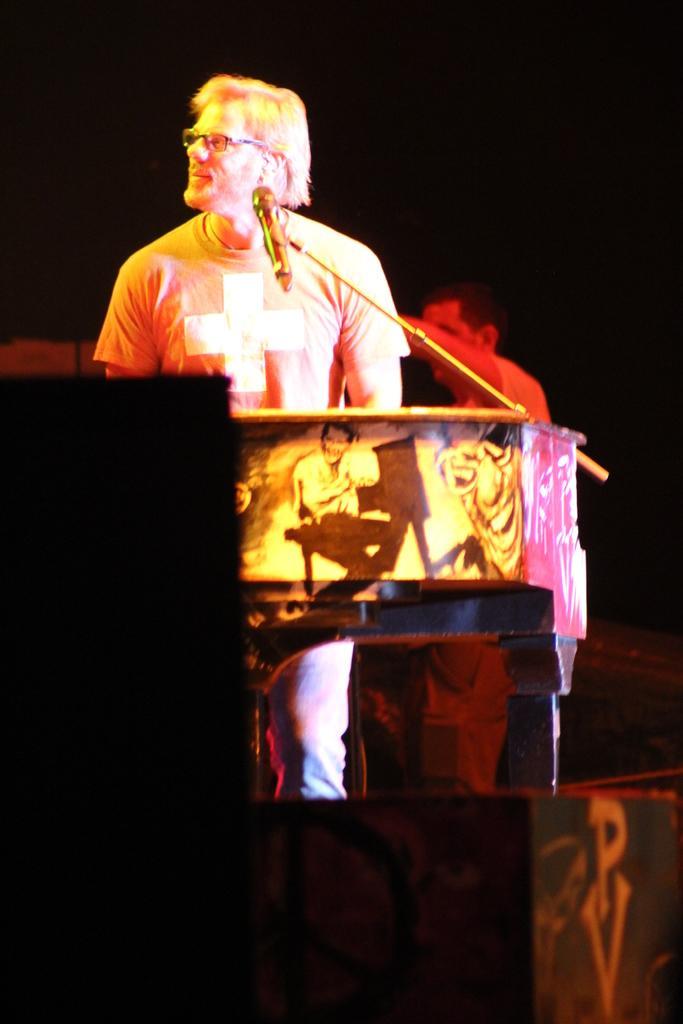Can you describe this image briefly? On the left side, there is a person in a t-shirt, standing in front of a mic which is attached to a stand and a musical instrument which is arranged on a stage, on which there are speakers. In the background, there is another person. And the background is dark in color. 